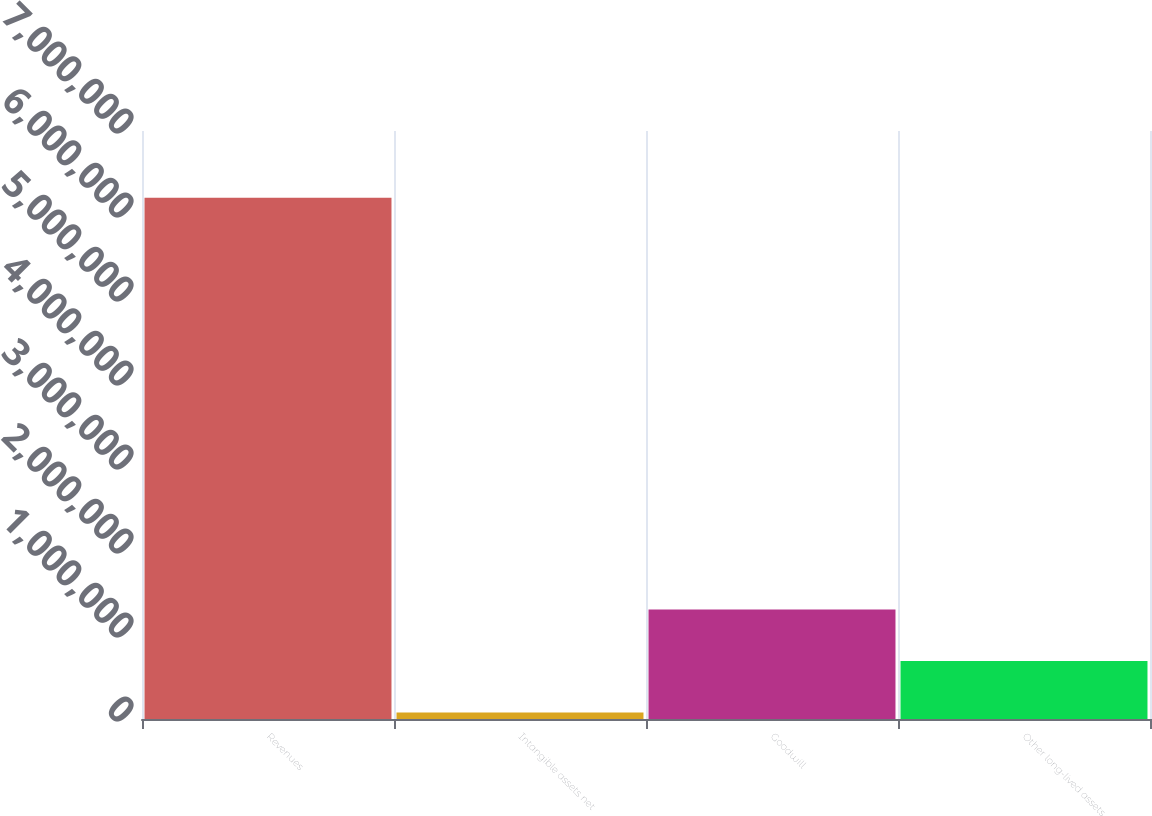Convert chart to OTSL. <chart><loc_0><loc_0><loc_500><loc_500><bar_chart><fcel>Revenues<fcel>Intangible assets net<fcel>Goodwill<fcel>Other long-lived assets<nl><fcel>6.20512e+06<fcel>78027<fcel>1.30344e+06<fcel>690736<nl></chart> 